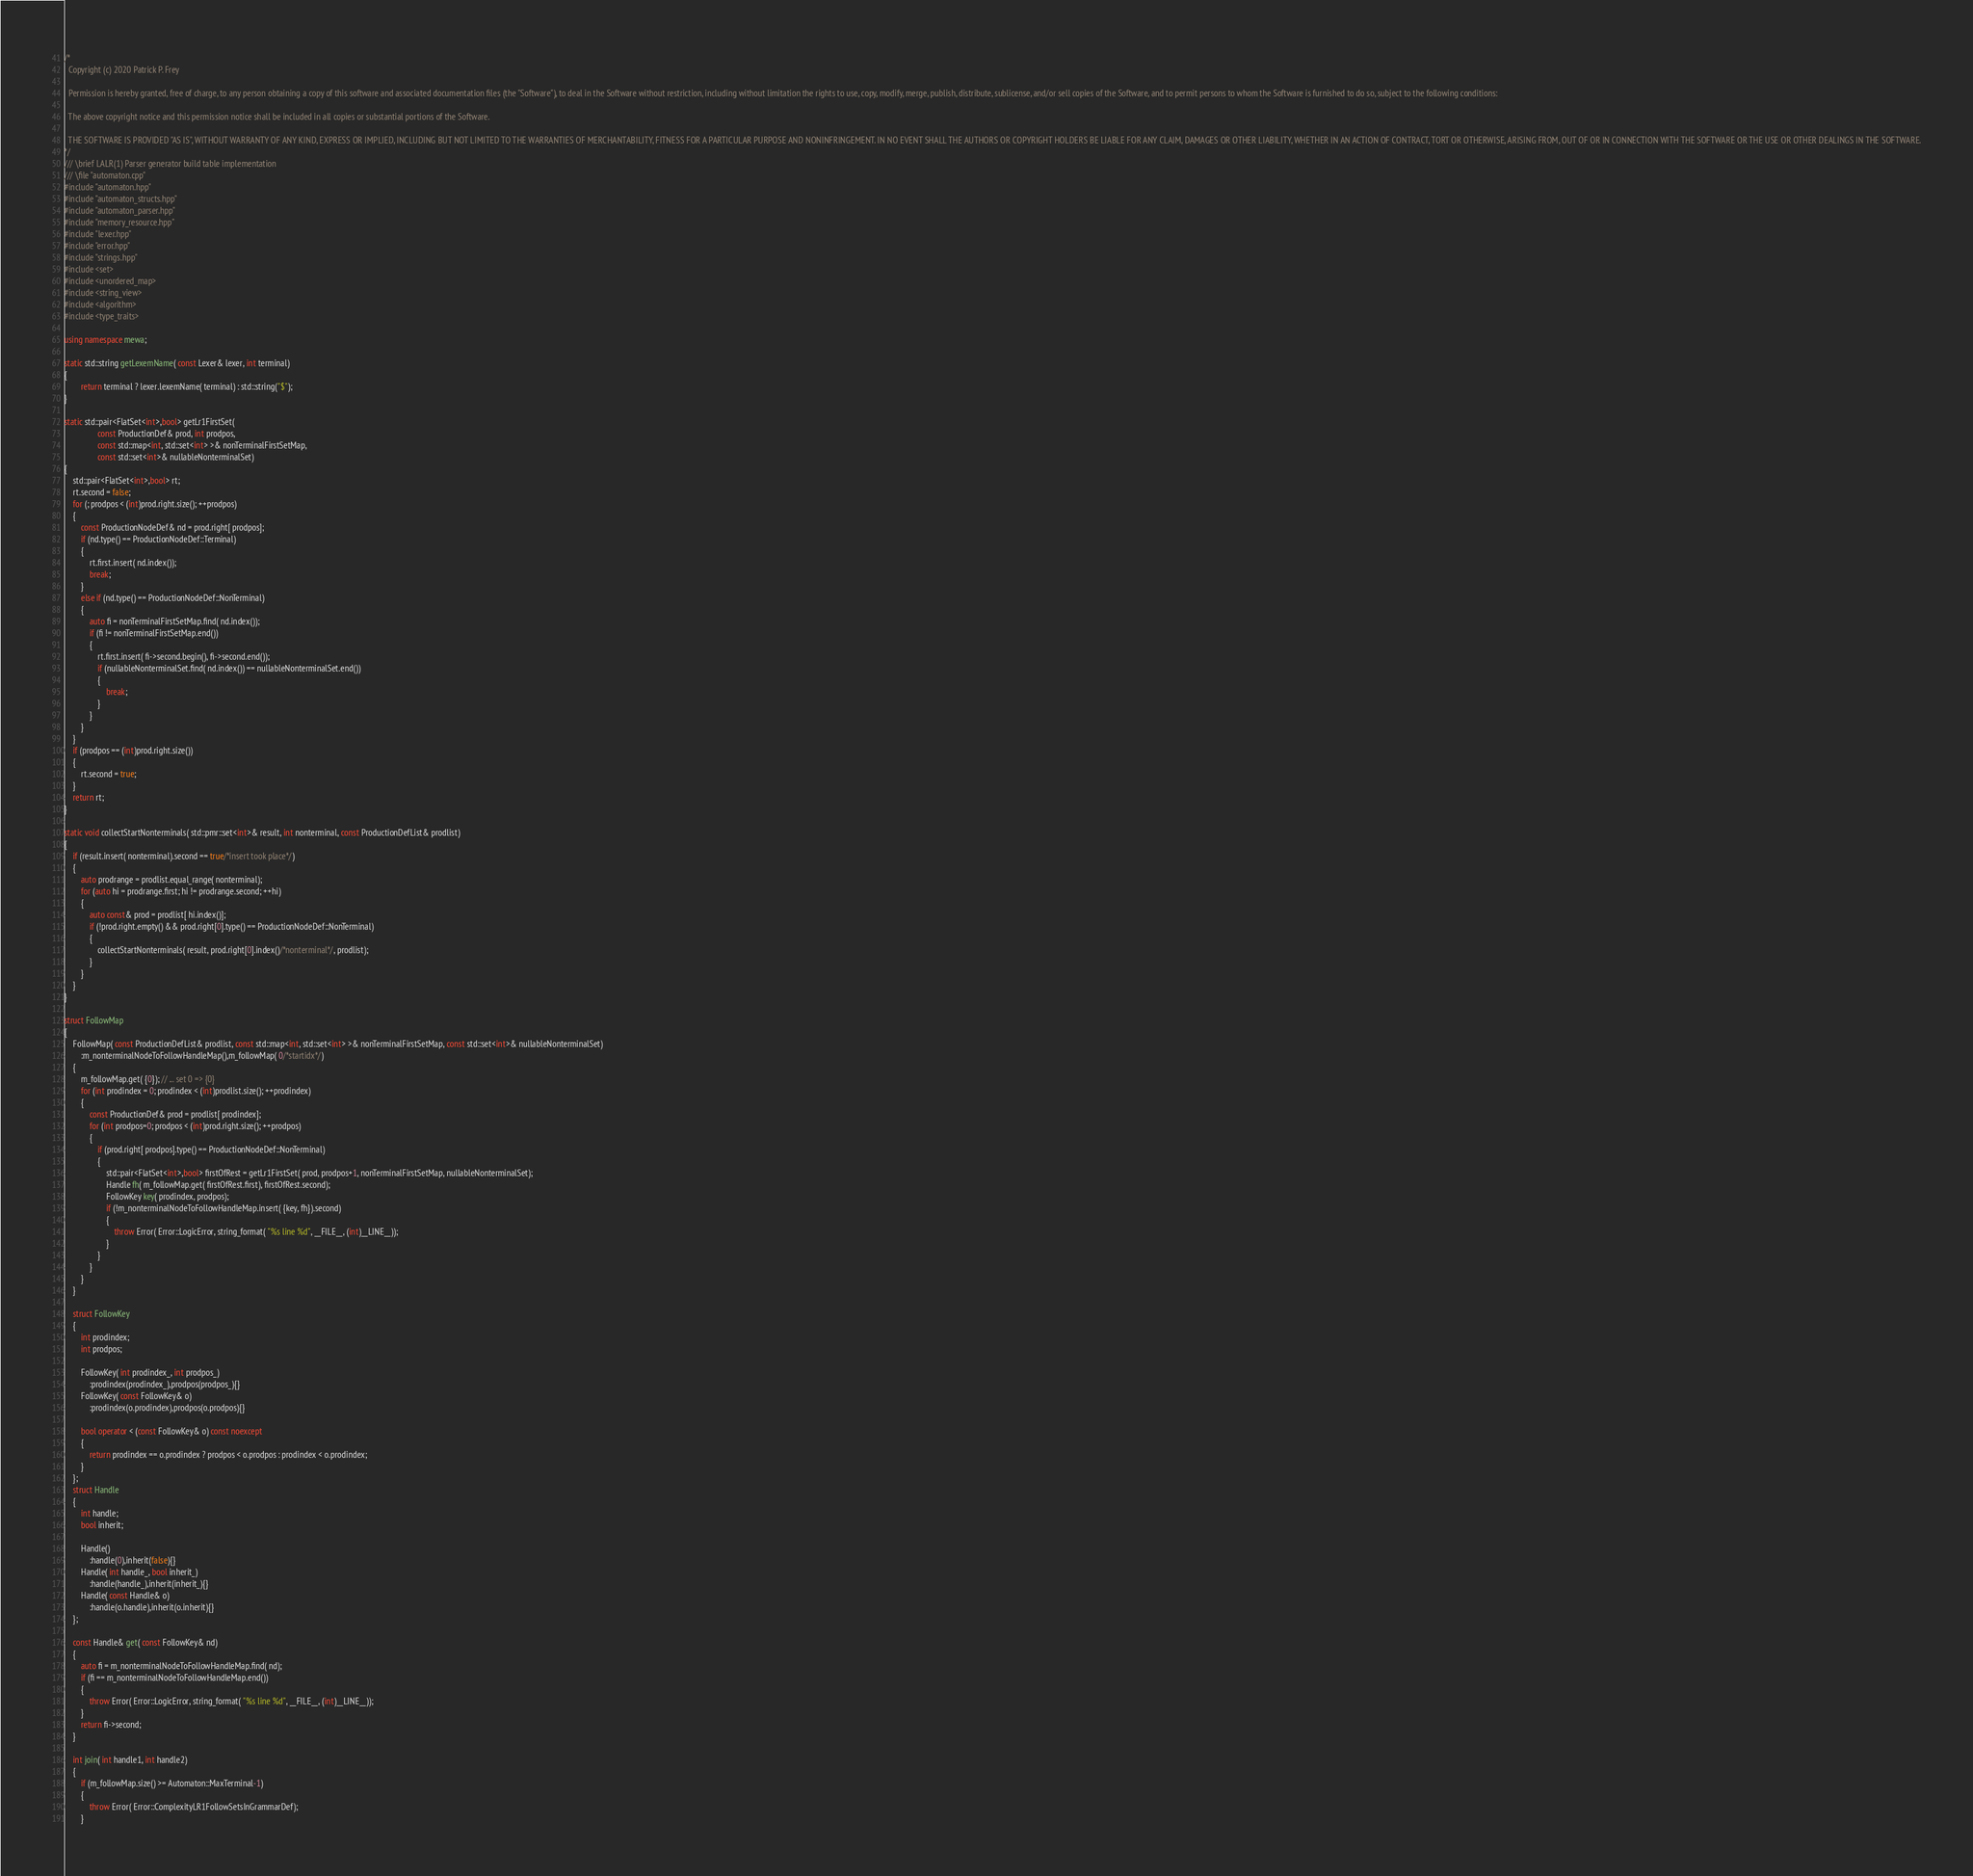Convert code to text. <code><loc_0><loc_0><loc_500><loc_500><_C++_>/*
  Copyright (c) 2020 Patrick P. Frey
 
  Permission is hereby granted, free of charge, to any person obtaining a copy of this software and associated documentation files (the "Software"), to deal in the Software without restriction, including without limitation the rights to use, copy, modify, merge, publish, distribute, sublicense, and/or sell copies of the Software, and to permit persons to whom the Software is furnished to do so, subject to the following conditions:

  The above copyright notice and this permission notice shall be included in all copies or substantial portions of the Software.

  THE SOFTWARE IS PROVIDED "AS IS", WITHOUT WARRANTY OF ANY KIND, EXPRESS OR IMPLIED, INCLUDING BUT NOT LIMITED TO THE WARRANTIES OF MERCHANTABILITY, FITNESS FOR A PARTICULAR PURPOSE AND NONINFRINGEMENT. IN NO EVENT SHALL THE AUTHORS OR COPYRIGHT HOLDERS BE LIABLE FOR ANY CLAIM, DAMAGES OR OTHER LIABILITY, WHETHER IN AN ACTION OF CONTRACT, TORT OR OTHERWISE, ARISING FROM, OUT OF OR IN CONNECTION WITH THE SOFTWARE OR THE USE OR OTHER DEALINGS IN THE SOFTWARE.
*/
/// \brief LALR(1) Parser generator build table implementation
/// \file "automaton.cpp"
#include "automaton.hpp"
#include "automaton_structs.hpp"
#include "automaton_parser.hpp"
#include "memory_resource.hpp"
#include "lexer.hpp"
#include "error.hpp"
#include "strings.hpp"
#include <set>
#include <unordered_map>
#include <string_view>
#include <algorithm>
#include <type_traits>

using namespace mewa;

static std::string getLexemName( const Lexer& lexer, int terminal)
{
        return terminal ? lexer.lexemName( terminal) : std::string("$");
}

static std::pair<FlatSet<int>,bool> getLr1FirstSet(
				const ProductionDef& prod, int prodpos, 
				const std::map<int, std::set<int> >& nonTerminalFirstSetMap,
				const std::set<int>& nullableNonterminalSet)
{
	std::pair<FlatSet<int>,bool> rt;
	rt.second = false;
	for (; prodpos < (int)prod.right.size(); ++prodpos)
	{
		const ProductionNodeDef& nd = prod.right[ prodpos];
		if (nd.type() == ProductionNodeDef::Terminal)
		{
			rt.first.insert( nd.index());
			break;
		}
		else if (nd.type() == ProductionNodeDef::NonTerminal)
		{
			auto fi = nonTerminalFirstSetMap.find( nd.index());
			if (fi != nonTerminalFirstSetMap.end())
			{
				rt.first.insert( fi->second.begin(), fi->second.end());
				if (nullableNonterminalSet.find( nd.index()) == nullableNonterminalSet.end())
				{
					break;
				}
			}
		}
	}
	if (prodpos == (int)prod.right.size())
	{
		rt.second = true;
	}
	return rt;
}

static void collectStartNonterminals( std::pmr::set<int>& result, int nonterminal, const ProductionDefList& prodlist)
{
	if (result.insert( nonterminal).second == true/*insert took place*/)
	{
		auto prodrange = prodlist.equal_range( nonterminal);
		for (auto hi = prodrange.first; hi != prodrange.second; ++hi)
		{
			auto const& prod = prodlist[ hi.index()];
			if (!prod.right.empty() && prod.right[0].type() == ProductionNodeDef::NonTerminal)
			{
				collectStartNonterminals( result, prod.right[0].index()/*nonterminal*/, prodlist);
			}
		}
	}
}

struct FollowMap
{
	FollowMap( const ProductionDefList& prodlist, const std::map<int, std::set<int> >& nonTerminalFirstSetMap, const std::set<int>& nullableNonterminalSet)
		:m_nonterminalNodeToFollowHandleMap(),m_followMap( 0/*startidx*/)
	{
		m_followMap.get( {0}); // ... set 0 => {0}
		for (int prodindex = 0; prodindex < (int)prodlist.size(); ++prodindex)
		{
			const ProductionDef& prod = prodlist[ prodindex];
			for (int prodpos=0; prodpos < (int)prod.right.size(); ++prodpos)
			{
				if (prod.right[ prodpos].type() == ProductionNodeDef::NonTerminal)
				{
					std::pair<FlatSet<int>,bool> firstOfRest = getLr1FirstSet( prod, prodpos+1, nonTerminalFirstSetMap, nullableNonterminalSet);
					Handle fh( m_followMap.get( firstOfRest.first), firstOfRest.second);
					FollowKey key( prodindex, prodpos);
					if (!m_nonterminalNodeToFollowHandleMap.insert( {key, fh}).second)
					{
						throw Error( Error::LogicError, string_format( "%s line %d", __FILE__, (int)__LINE__));
					}
				}
			}
		}
	}

	struct FollowKey
	{
		int prodindex;
		int prodpos;

		FollowKey( int prodindex_, int prodpos_)
			:prodindex(prodindex_),prodpos(prodpos_){}
		FollowKey( const FollowKey& o)
			:prodindex(o.prodindex),prodpos(o.prodpos){}

		bool operator < (const FollowKey& o) const noexcept
		{
			return prodindex == o.prodindex ? prodpos < o.prodpos : prodindex < o.prodindex;
		}
	};
	struct Handle
	{
		int handle;
		bool inherit;

		Handle()
			:handle(0),inherit(false){}
		Handle( int handle_, bool inherit_)
			:handle(handle_),inherit(inherit_){}
		Handle( const Handle& o)
			:handle(o.handle),inherit(o.inherit){}
	};

	const Handle& get( const FollowKey& nd)
	{
		auto fi = m_nonterminalNodeToFollowHandleMap.find( nd);
		if (fi == m_nonterminalNodeToFollowHandleMap.end())
		{
			throw Error( Error::LogicError, string_format( "%s line %d", __FILE__, (int)__LINE__));
		}
		return fi->second;
	}

	int join( int handle1, int handle2)
	{
		if (m_followMap.size() >= Automaton::MaxTerminal-1)
		{
			throw Error( Error::ComplexityLR1FollowSetsInGrammarDef);
		}</code> 